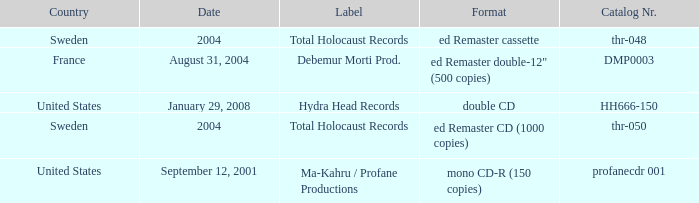Which country has the catalog nr of thr-048 in 2004? Sweden. 